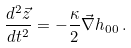Convert formula to latex. <formula><loc_0><loc_0><loc_500><loc_500>\frac { d ^ { 2 } \vec { z } } { d t ^ { 2 } } = - \frac { \kappa } { 2 } \vec { \nabla } h _ { 0 0 } \, .</formula> 